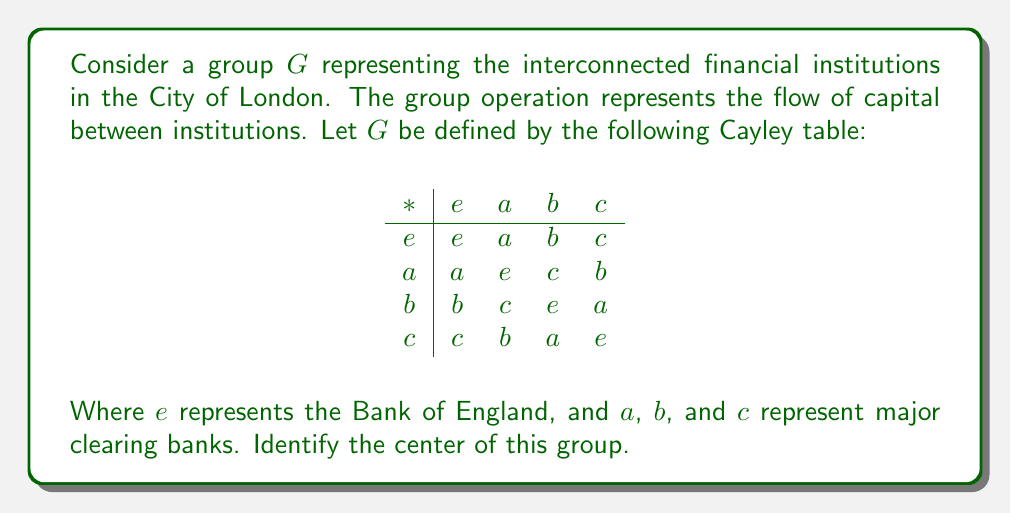Can you answer this question? To find the center of the group $G$, we need to identify all elements that commute with every element in the group. Let's approach this step-by-step:

1) First, recall that the center of a group $G$ is defined as:
   $Z(G) = \{z \in G : zg = gz \text{ for all } g \in G\}$

2) We need to check each element's commutativity with all other elements:

   For $e$:
   - $e * a = a * e = a$
   - $e * b = b * e = b$
   - $e * c = c * e = c$
   $e$ commutes with all elements.

   For $a$:
   - $a * b = c \neq b = b * a$
   - $a * c = b \neq c = c * a$
   $a$ does not commute with $b$ and $c$.

   For $b$:
   - $b * a = c \neq a = a * b$
   - $b * c = a \neq c = c * b$
   $b$ does not commute with $a$ and $c$.

   For $c$:
   - $c * a = b \neq a = a * c$
   - $c * b = a \neq b = b * c$
   $c$ does not commute with $a$ and $b$.

3) From this analysis, we can see that only $e$ commutes with all elements of the group.

Therefore, the center of the group $G$ consists only of the identity element $e$, which represents the Bank of England in our financial context.
Answer: The center of the group $G$ is $Z(G) = \{e\}$, where $e$ represents the Bank of England. 